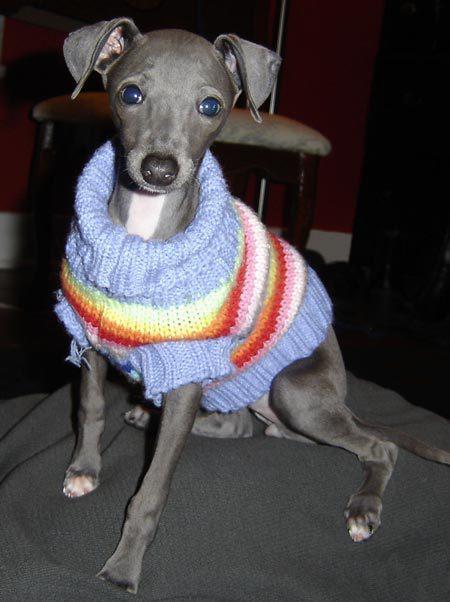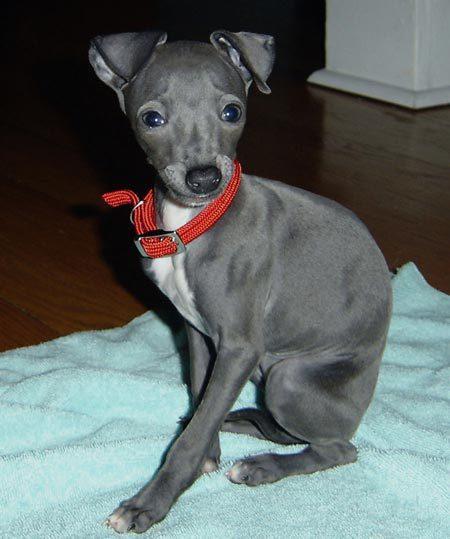The first image is the image on the left, the second image is the image on the right. Considering the images on both sides, is "The dog in the right image has a red collar around its neck." valid? Answer yes or no. Yes. The first image is the image on the left, the second image is the image on the right. Analyze the images presented: Is the assertion "There are two dogs in total and one of them is wearing a collar." valid? Answer yes or no. Yes. 